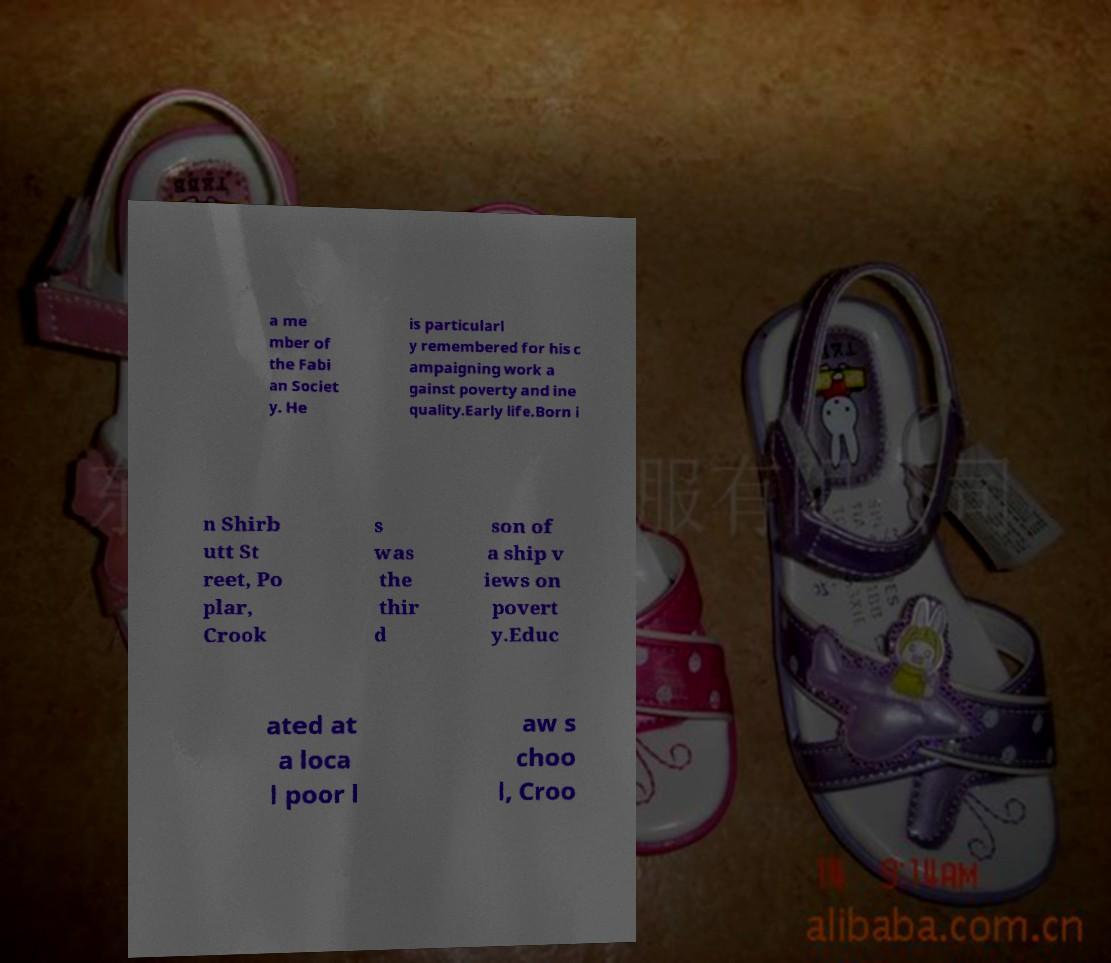Can you read and provide the text displayed in the image?This photo seems to have some interesting text. Can you extract and type it out for me? a me mber of the Fabi an Societ y. He is particularl y remembered for his c ampaigning work a gainst poverty and ine quality.Early life.Born i n Shirb utt St reet, Po plar, Crook s was the thir d son of a ship v iews on povert y.Educ ated at a loca l poor l aw s choo l, Croo 